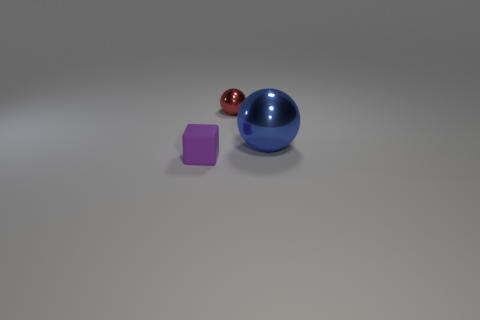Add 3 purple blocks. How many objects exist? 6 Subtract all red spheres. How many spheres are left? 1 Subtract 2 spheres. How many spheres are left? 0 Subtract all small blue metal objects. Subtract all small red metal balls. How many objects are left? 2 Add 3 shiny balls. How many shiny balls are left? 5 Add 3 tiny balls. How many tiny balls exist? 4 Subtract 1 purple cubes. How many objects are left? 2 Subtract all balls. How many objects are left? 1 Subtract all green balls. Subtract all blue cylinders. How many balls are left? 2 